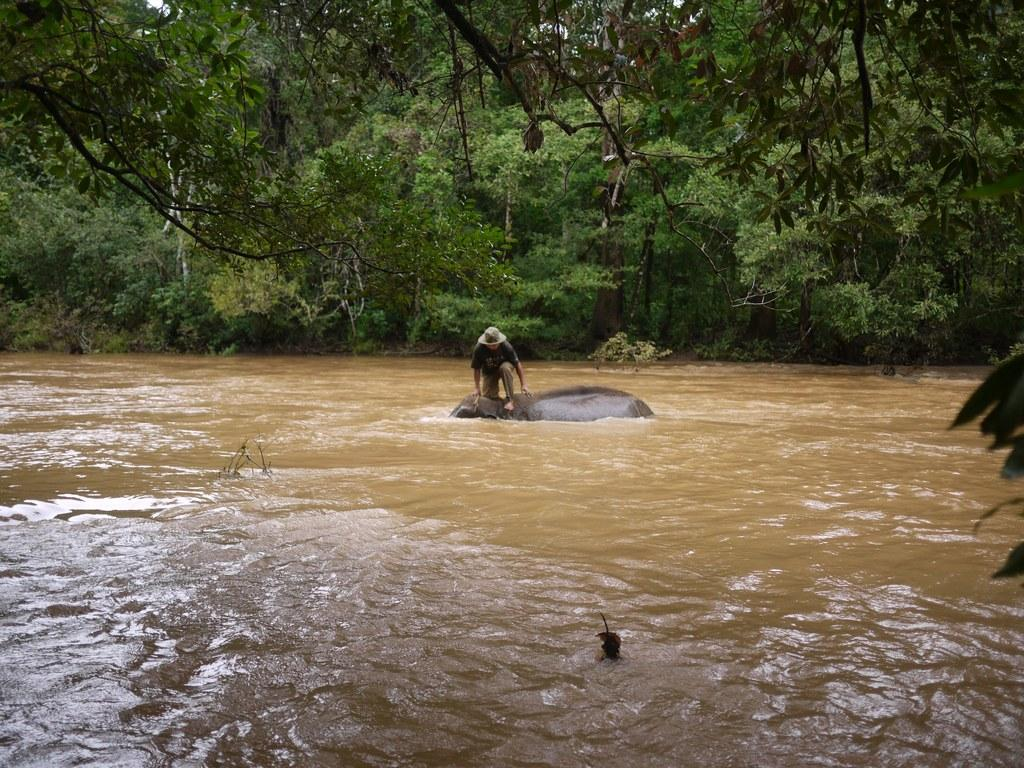What is the person doing in the image? The person is standing on an animal in the image. What is the environment like in the image? The person and animal are in water, and there are a few trees visible in the image. What type of activity is happening in the alley in the image? There is no alley present in the image, and therefore no activity can be observed in an alley. 